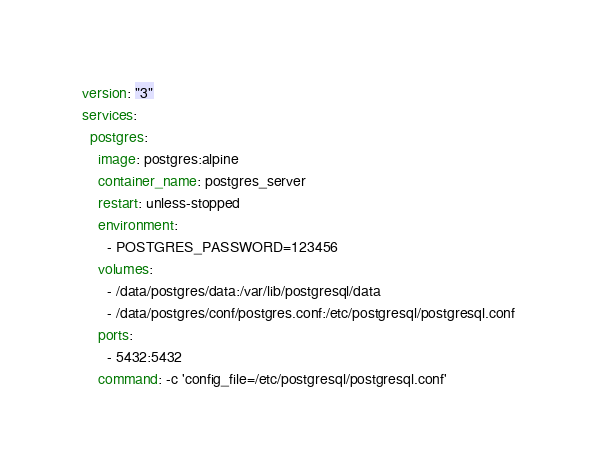Convert code to text. <code><loc_0><loc_0><loc_500><loc_500><_YAML_>version: "3"
services:
  postgres:
    image: postgres:alpine
    container_name: postgres_server
    restart: unless-stopped
    environment:
      - POSTGRES_PASSWORD=123456
    volumes:
      - /data/postgres/data:/var/lib/postgresql/data
      - /data/postgres/conf/postgres.conf:/etc/postgresql/postgresql.conf
    ports:
      - 5432:5432
    command: -c 'config_file=/etc/postgresql/postgresql.conf'
</code> 